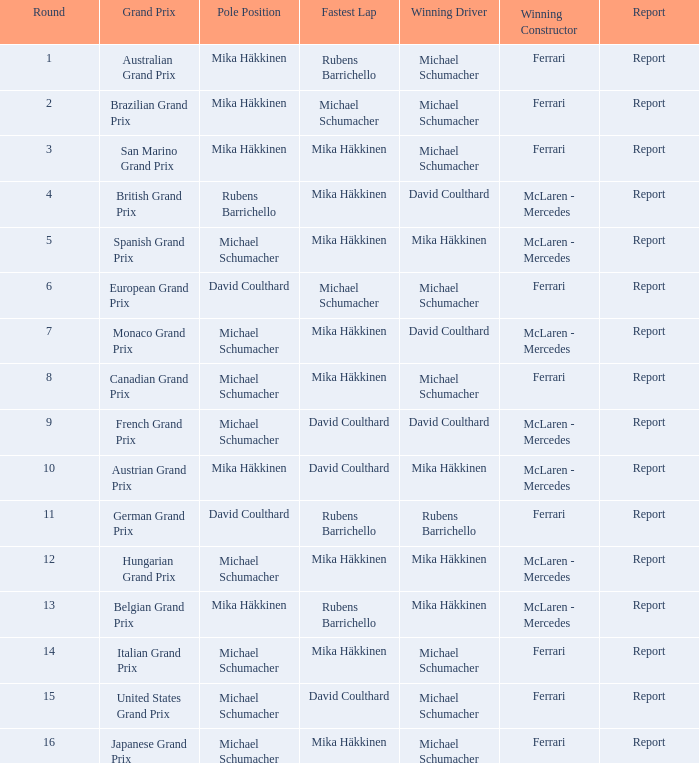Who had the fastest lap in the Belgian Grand Prix? Rubens Barrichello. 